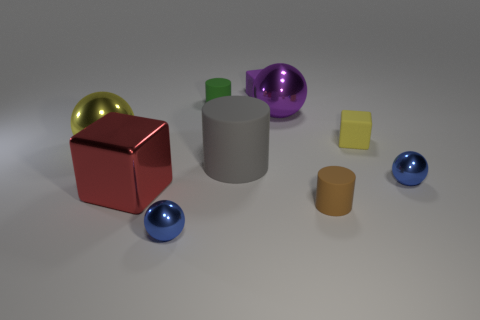Subtract 1 balls. How many balls are left? 3 Subtract all green balls. Subtract all gray cylinders. How many balls are left? 4 Subtract all blocks. How many objects are left? 7 Subtract all tiny yellow matte balls. Subtract all green rubber cylinders. How many objects are left? 9 Add 7 purple metal things. How many purple metal things are left? 8 Add 4 small cubes. How many small cubes exist? 6 Subtract 0 blue cubes. How many objects are left? 10 